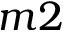<formula> <loc_0><loc_0><loc_500><loc_500>m 2</formula> 